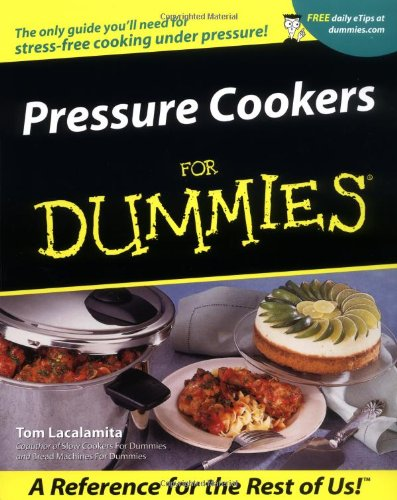Is this a recipe book? Yes, 'Pressure Cookers For Dummies' is primarily a recipe book, offering a range of cooking techniques and recipes for pressure cooker users. 